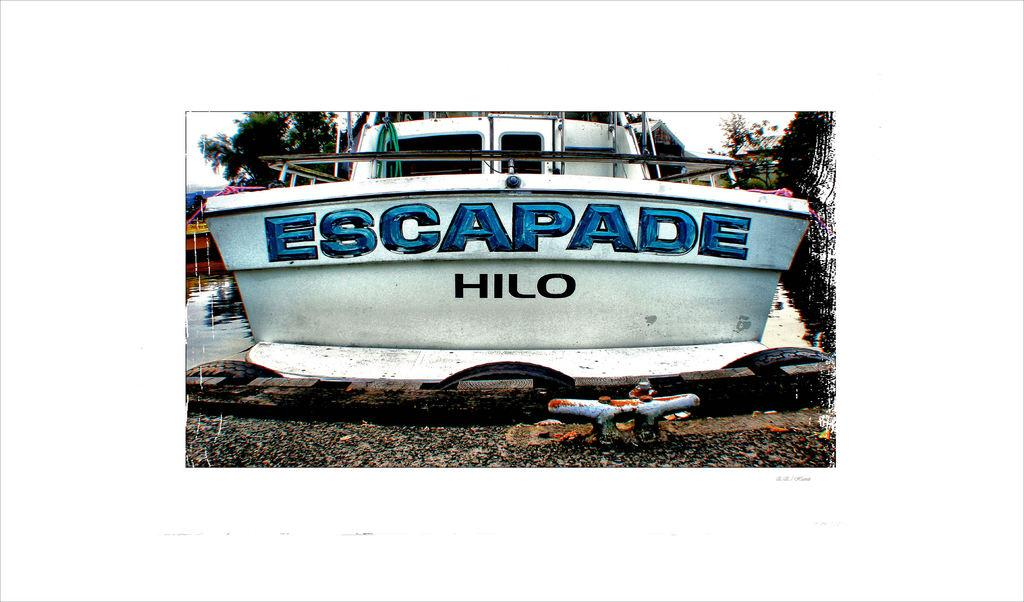<image>
Provide a brief description of the given image. "ESCAPADE HILO" is written on a white boat. 